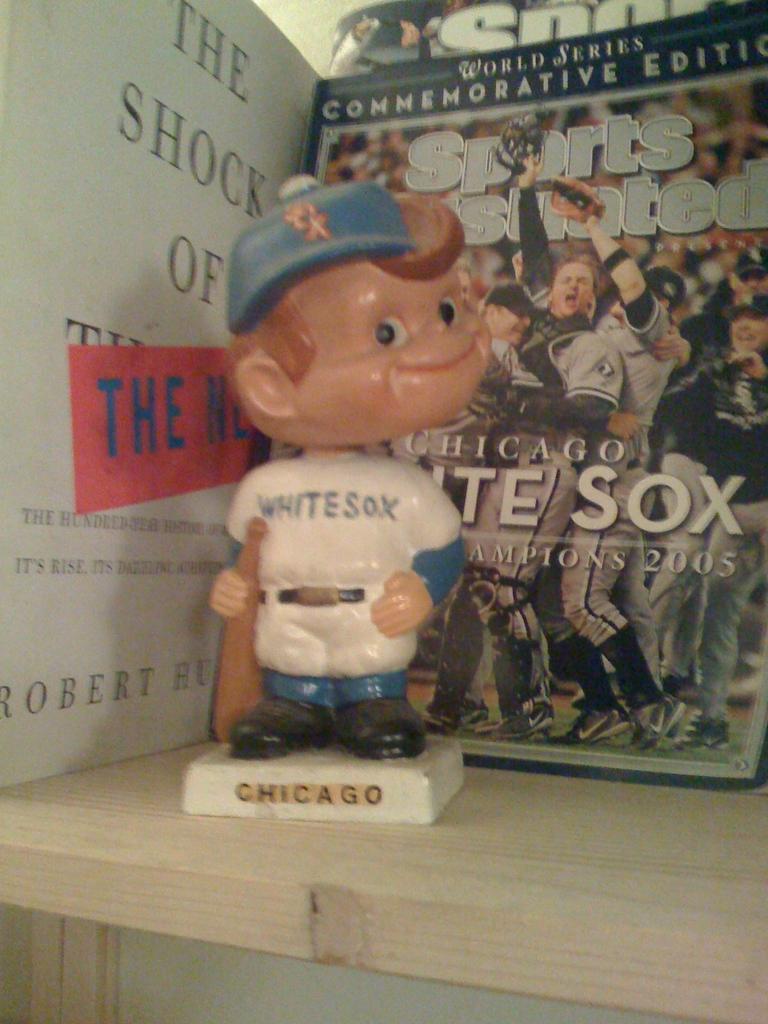Can you describe this image briefly? In the middle of the picture, we see a toy doll which is placed on the table. Behind that, we see a book which is placed on the table. On the left side, we see a white board or a book with some text written on it. 